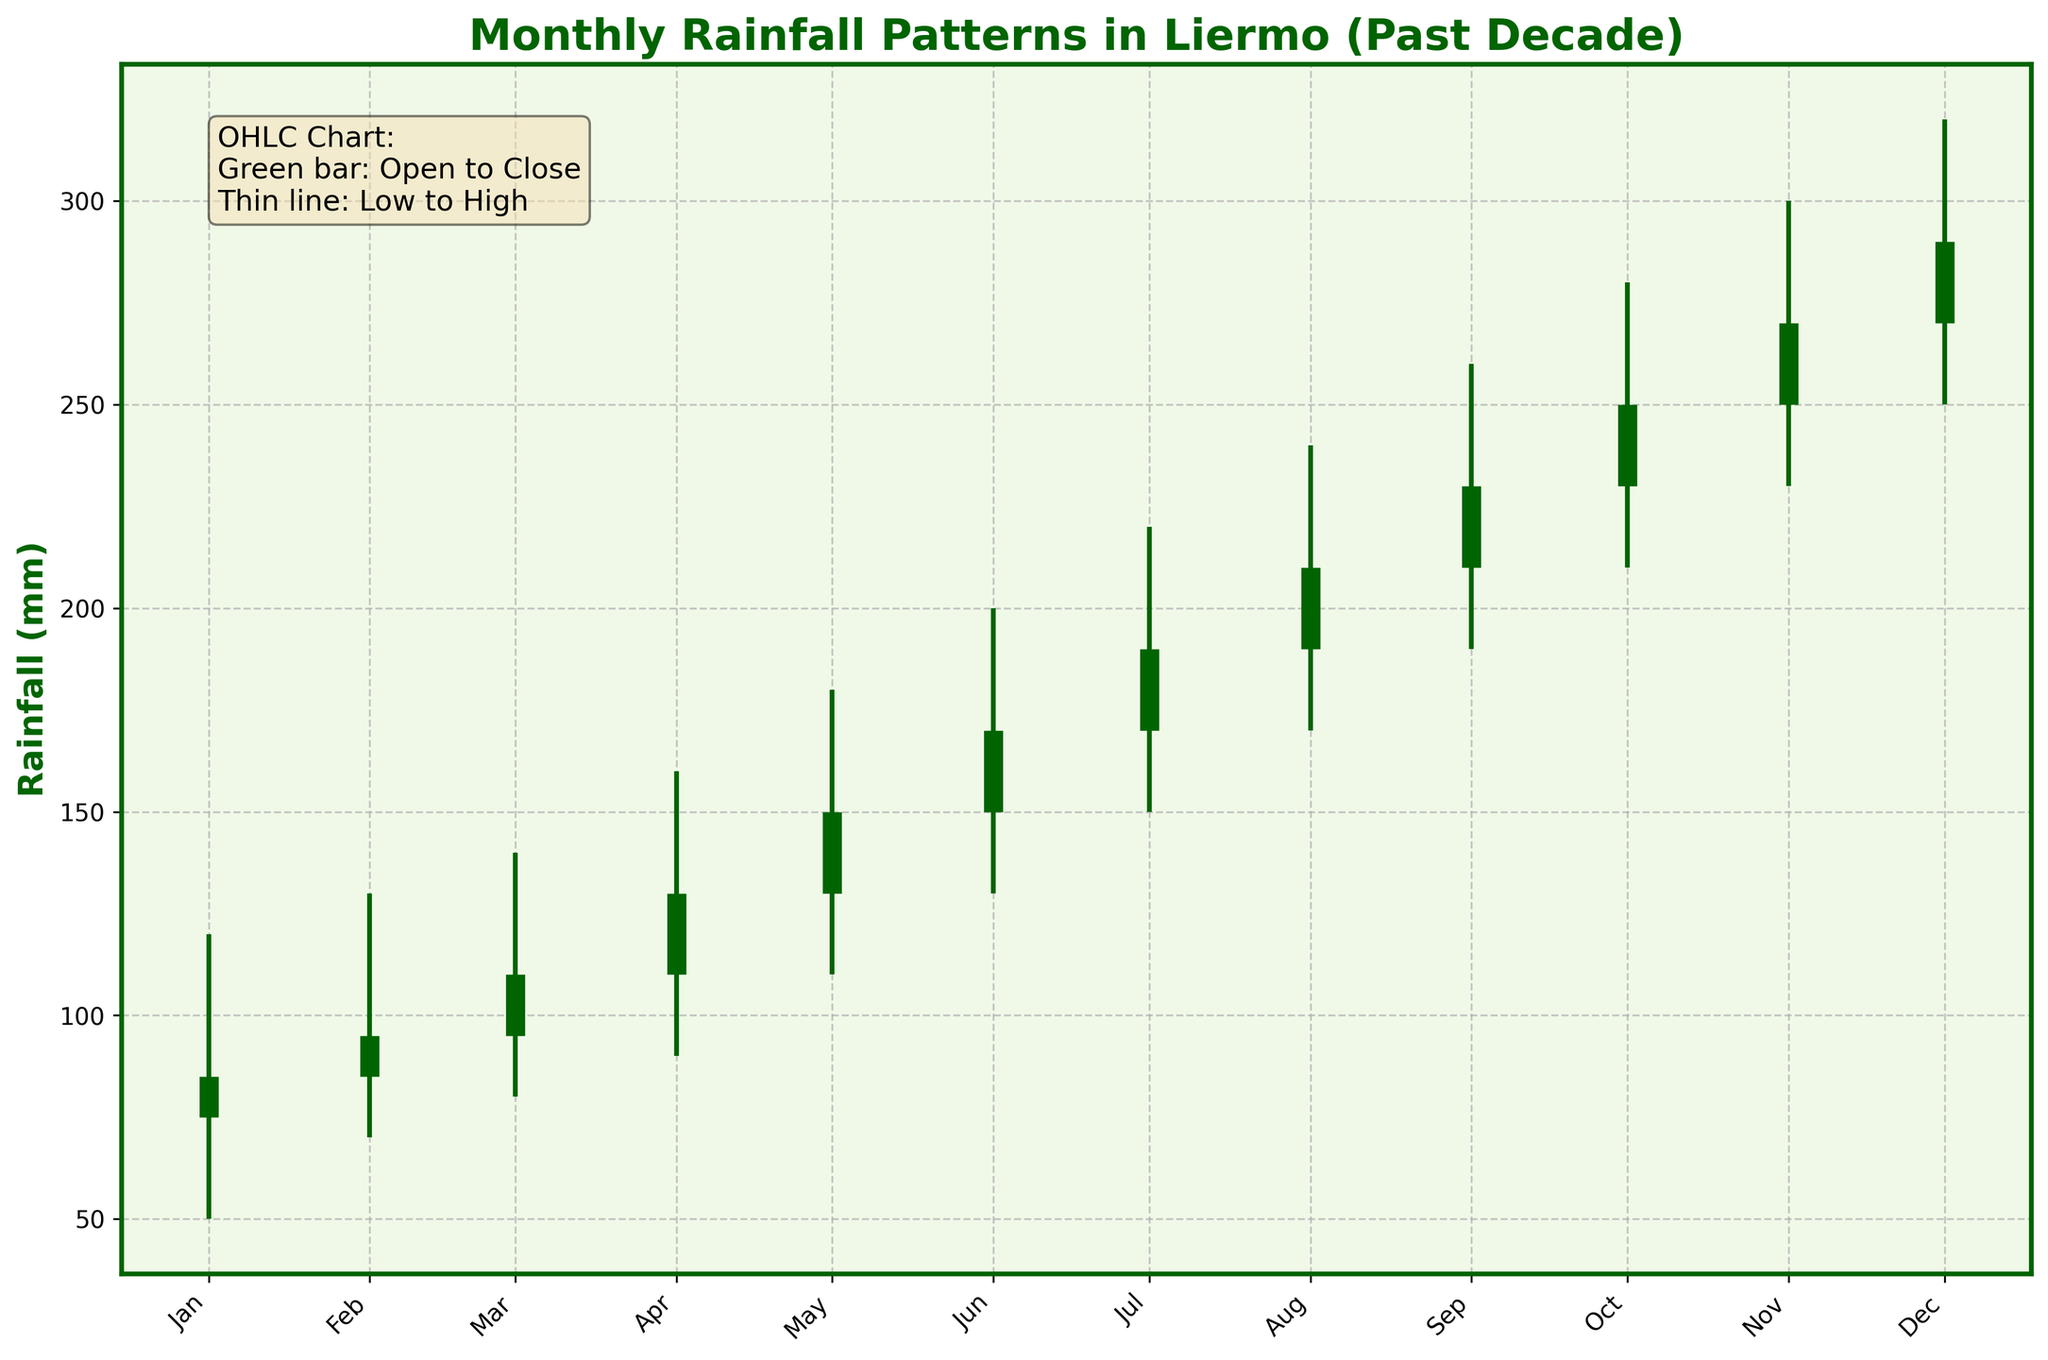What is the title of the figure? The title is found at the top of the figure in big, bold letters. It represents the overall content of the chart.
Answer: Monthly Rainfall Patterns in Liermo (Past Decade) What does a green bar represent in the figure? According to the legend-like text box in the figure, the green bar represents the range from the opening value to the closing value for each month.
Answer: Open to Close In which month did the rainfall have the widest range between the high and low values? By looking at the length of the thin vertical lines, the longest line represents the widest range. The longest line is in December, where the high is 320 mm and the low is 250 mm.
Answer: December Which month had the highest closing value of rainfall? By looking at the thick green bars and their ending points, we can identify that the closing value is highest in December at 290 mm.
Answer: December What is the difference between the highest and lowest rainfall in February? In February, the high value is 130 mm, and the low value is 70 mm. Calculating the difference: 130 - 70 = 60 mm.
Answer: 60 mm Which months had an increase in rainfall from open to close? Months show an increase if the close value is higher than the open value. These include every month since the closing values are consistently higher: January (85 > 75), February (95 > 85), etc.
Answer: All months What is the average closing value across the year? Add up all the closing values and divide by the number of months. (85 + 95 + 110 + 130 + 150 + 170 + 190 + 210 + 230 + 250 + 270 + 290)/12 = 188.75
Answer: 188.75 During which month was the rainfall at its lowest point, and what was the value? Identify the shortest thin green line, which indicates the lowest low value. The lowest point is 50 mm in January.
Answer: January, 50 mm How much did the opening value of rainfall increase from June to July? The opening value for June is 150 mm, for July is 170 mm, an increase of 170 - 150 = 20 mm.
Answer: 20 mm Did the high value of rainfall ever exceed 300 mm? If so, in which months? The high values exceed 300 mm in November (300 mm) and December (320 mm).
Answer: November and December 